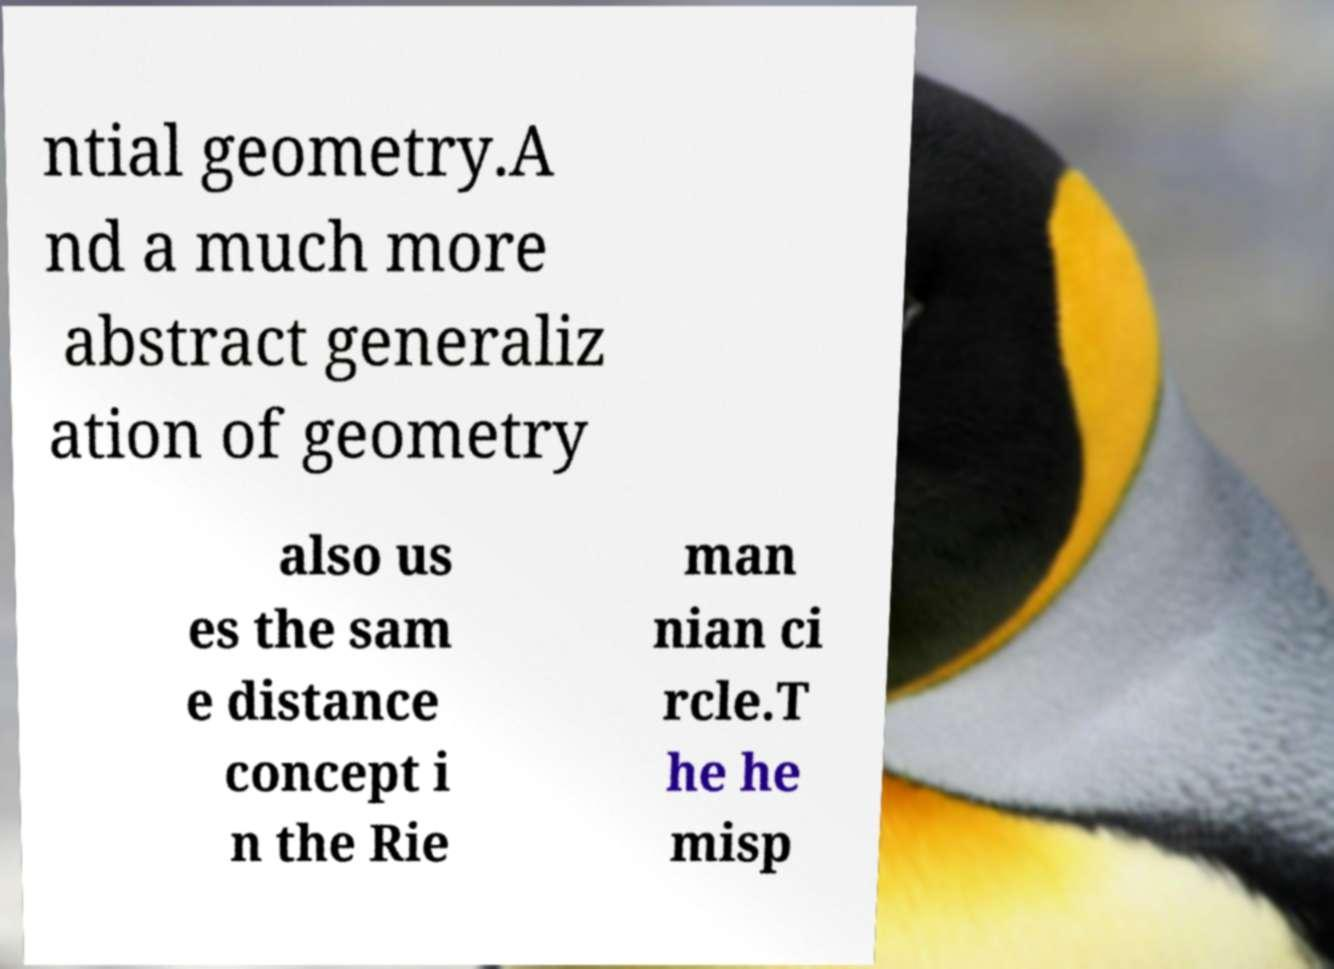Could you assist in decoding the text presented in this image and type it out clearly? ntial geometry.A nd a much more abstract generaliz ation of geometry also us es the sam e distance concept i n the Rie man nian ci rcle.T he he misp 